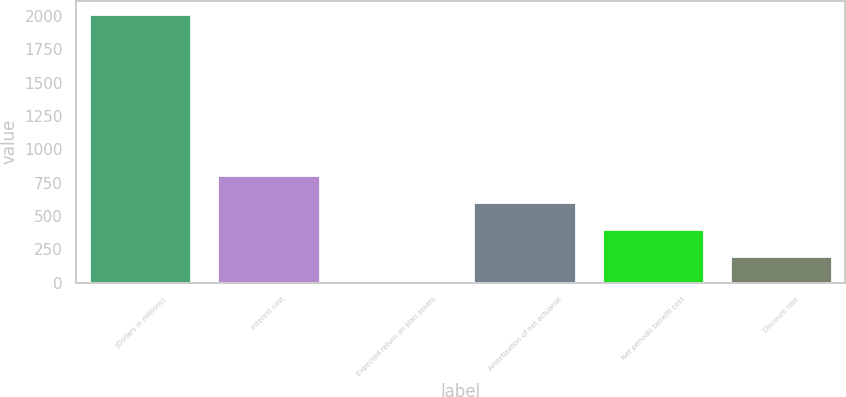Convert chart to OTSL. <chart><loc_0><loc_0><loc_500><loc_500><bar_chart><fcel>(Dollars in millions)<fcel>Interest cost<fcel>Expected return on plan assets<fcel>Amortization of net actuarial<fcel>Net periodic benefit cost<fcel>Discount rate<nl><fcel>2015<fcel>806.6<fcel>1<fcel>605.2<fcel>403.8<fcel>202.4<nl></chart> 